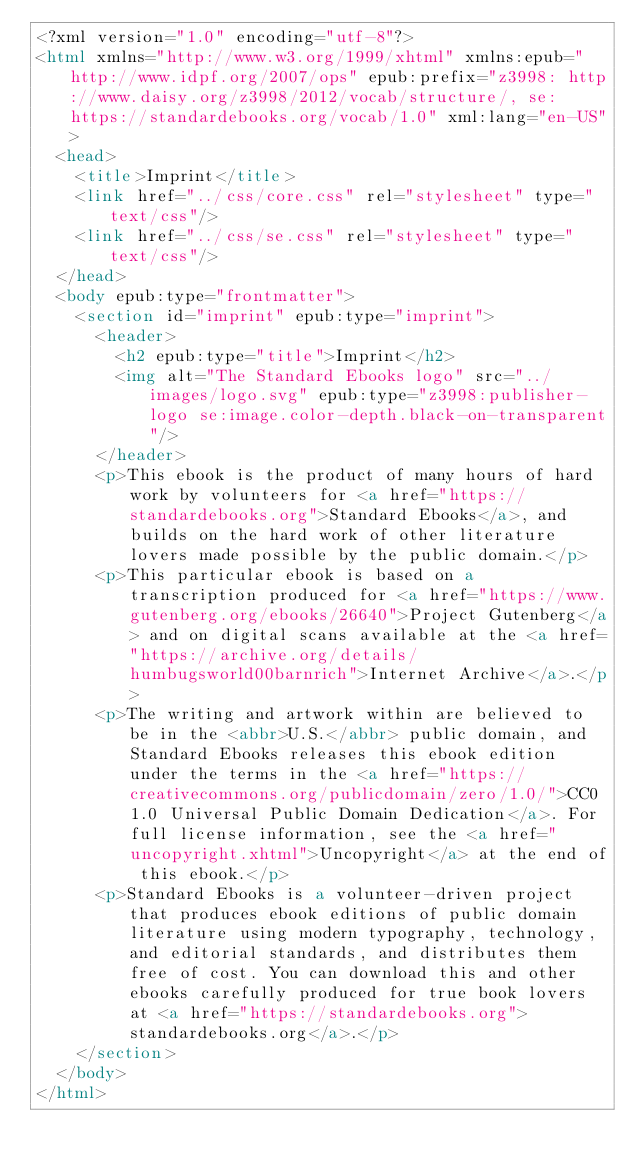Convert code to text. <code><loc_0><loc_0><loc_500><loc_500><_HTML_><?xml version="1.0" encoding="utf-8"?>
<html xmlns="http://www.w3.org/1999/xhtml" xmlns:epub="http://www.idpf.org/2007/ops" epub:prefix="z3998: http://www.daisy.org/z3998/2012/vocab/structure/, se: https://standardebooks.org/vocab/1.0" xml:lang="en-US">
	<head>
		<title>Imprint</title>
		<link href="../css/core.css" rel="stylesheet" type="text/css"/>
		<link href="../css/se.css" rel="stylesheet" type="text/css"/>
	</head>
	<body epub:type="frontmatter">
		<section id="imprint" epub:type="imprint">
			<header>
				<h2 epub:type="title">Imprint</h2>
				<img alt="The Standard Ebooks logo" src="../images/logo.svg" epub:type="z3998:publisher-logo se:image.color-depth.black-on-transparent"/>
			</header>
			<p>This ebook is the product of many hours of hard work by volunteers for <a href="https://standardebooks.org">Standard Ebooks</a>, and builds on the hard work of other literature lovers made possible by the public domain.</p>
			<p>This particular ebook is based on a transcription produced for <a href="https://www.gutenberg.org/ebooks/26640">Project Gutenberg</a> and on digital scans available at the <a href="https://archive.org/details/humbugsworld00barnrich">Internet Archive</a>.</p>
			<p>The writing and artwork within are believed to be in the <abbr>U.S.</abbr> public domain, and Standard Ebooks releases this ebook edition under the terms in the <a href="https://creativecommons.org/publicdomain/zero/1.0/">CC0 1.0 Universal Public Domain Dedication</a>. For full license information, see the <a href="uncopyright.xhtml">Uncopyright</a> at the end of this ebook.</p>
			<p>Standard Ebooks is a volunteer-driven project that produces ebook editions of public domain literature using modern typography, technology, and editorial standards, and distributes them free of cost. You can download this and other ebooks carefully produced for true book lovers at <a href="https://standardebooks.org">standardebooks.org</a>.</p>
		</section>
	</body>
</html>
</code> 